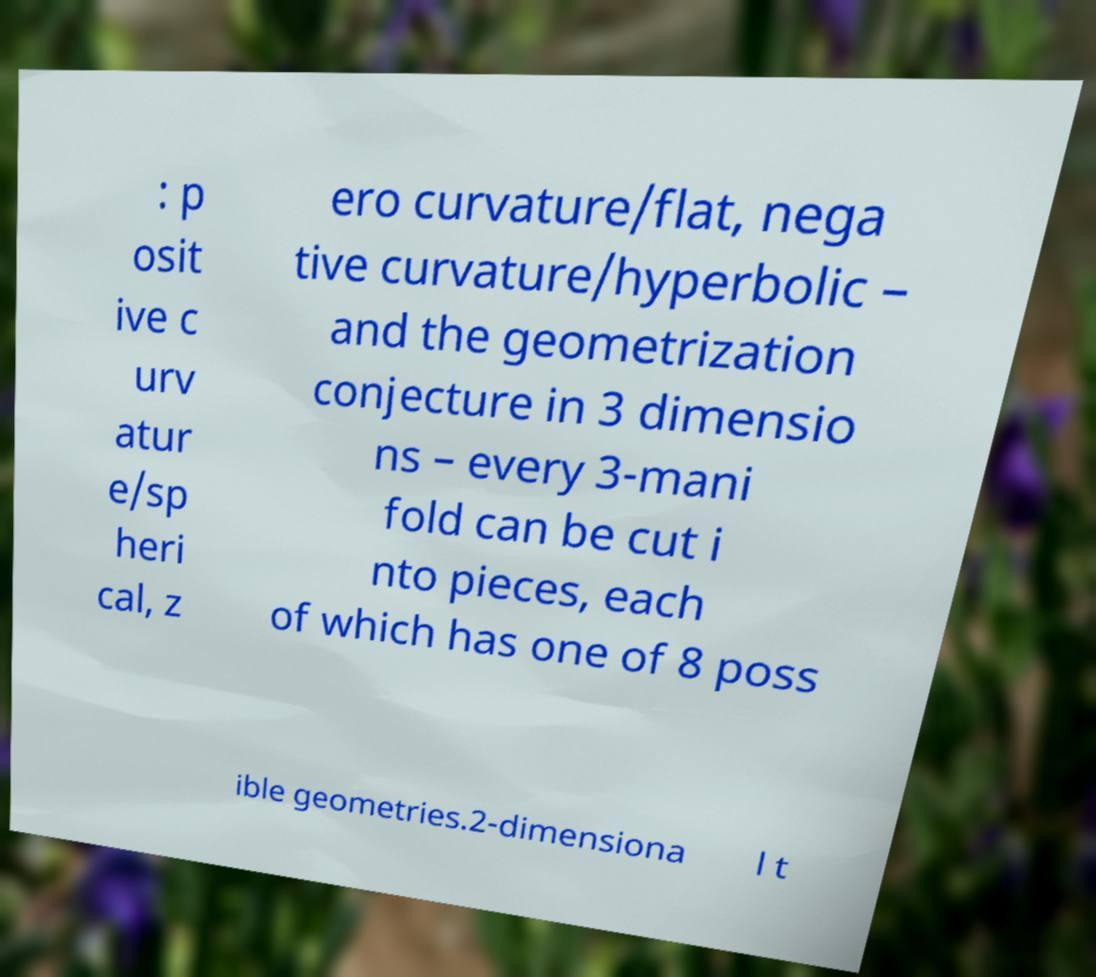Could you extract and type out the text from this image? : p osit ive c urv atur e/sp heri cal, z ero curvature/flat, nega tive curvature/hyperbolic – and the geometrization conjecture in 3 dimensio ns – every 3-mani fold can be cut i nto pieces, each of which has one of 8 poss ible geometries.2-dimensiona l t 